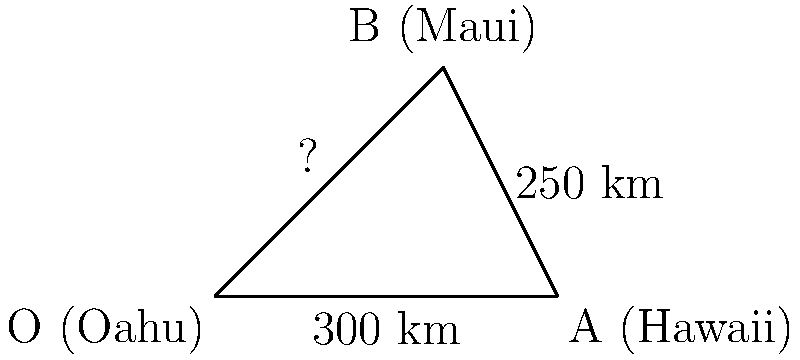Aloha! Remember when we used to watch the 'iwa (frigatebirds) soar between the islands? Let's calculate the distance of their flight path from Oahu to Maui. Given that the distance from Oahu to Hawaii (Big Island) is 300 km, and from Hawaii to Maui is 250 km, with an angle of 60° between these two paths, what is the magnitude of the vector representing the direct flight path from Oahu to Maui? Let's approach this step-by-step using the law of cosines:

1) Let's define our vectors:
   $\vec{OA}$ (Oahu to Hawaii) = 300 km
   $\vec{AB}$ (Hawaii to Maui) = 250 km
   $\vec{OB}$ (Oahu to Maui) = unknown (let's call it x)

2) The law of cosines states:
   $x^2 = OA^2 + AB^2 - 2(OA)(AB)\cos(\theta)$

3) We know:
   $OA = 300$ km
   $AB = 250$ km
   $\theta = 60°$

4) Let's substitute these values:
   $x^2 = 300^2 + 250^2 - 2(300)(250)\cos(60°)$

5) Simplify:
   $x^2 = 90,000 + 62,500 - 150,000 \cdot 0.5$
   $x^2 = 152,500 - 75,000$
   $x^2 = 77,500$

6) Take the square root of both sides:
   $x = \sqrt{77,500} \approx 278.4$ km

Therefore, the magnitude of the vector representing the direct flight path from Oahu to Maui is approximately 278.4 km.
Answer: 278.4 km 